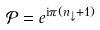<formula> <loc_0><loc_0><loc_500><loc_500>\mathcal { P } = e ^ { \text {i} \pi ( n _ { \downarrow } + 1 ) }</formula> 